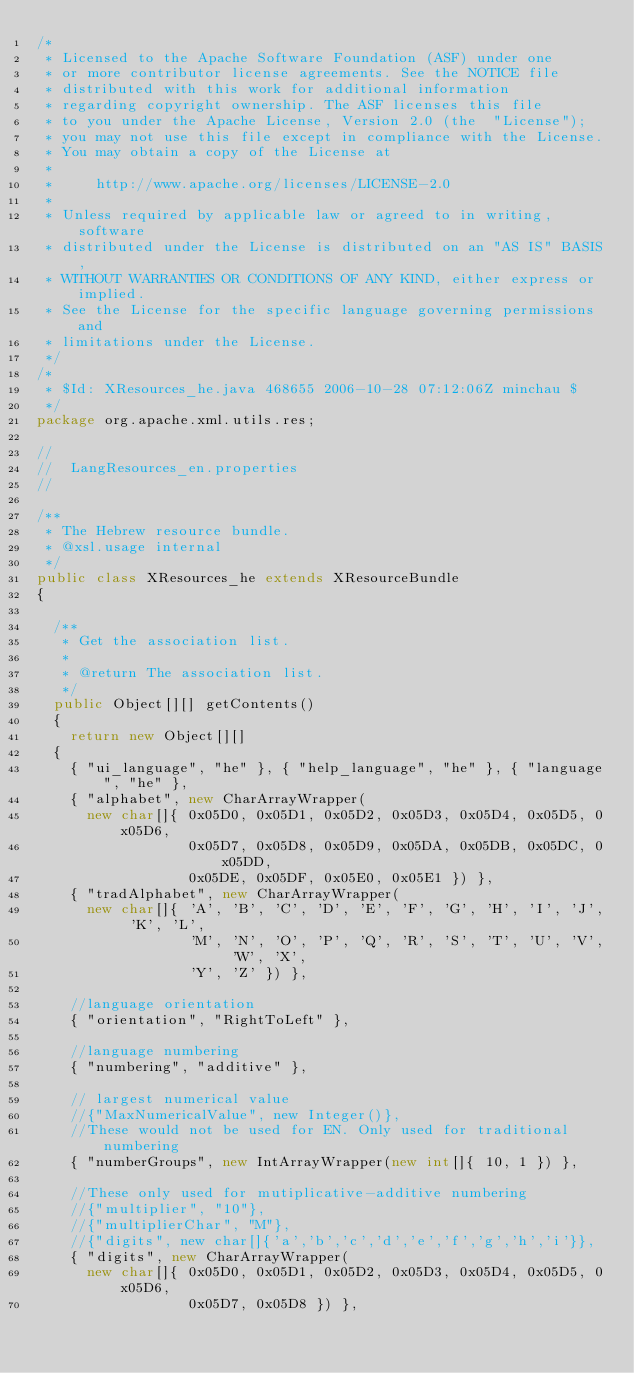Convert code to text. <code><loc_0><loc_0><loc_500><loc_500><_Java_>/*
 * Licensed to the Apache Software Foundation (ASF) under one
 * or more contributor license agreements. See the NOTICE file
 * distributed with this work for additional information
 * regarding copyright ownership. The ASF licenses this file
 * to you under the Apache License, Version 2.0 (the  "License");
 * you may not use this file except in compliance with the License.
 * You may obtain a copy of the License at
 *
 *     http://www.apache.org/licenses/LICENSE-2.0
 *
 * Unless required by applicable law or agreed to in writing, software
 * distributed under the License is distributed on an "AS IS" BASIS,
 * WITHOUT WARRANTIES OR CONDITIONS OF ANY KIND, either express or implied.
 * See the License for the specific language governing permissions and
 * limitations under the License.
 */
/*
 * $Id: XResources_he.java 468655 2006-10-28 07:12:06Z minchau $
 */
package org.apache.xml.utils.res;

//
//  LangResources_en.properties
//

/**
 * The Hebrew resource bundle.
 * @xsl.usage internal
 */
public class XResources_he extends XResourceBundle
{

  /**
   * Get the association list.
   *
   * @return The association list.
   */
  public Object[][] getContents()
  {
    return new Object[][]
  {
    { "ui_language", "he" }, { "help_language", "he" }, { "language", "he" },
    { "alphabet", new CharArrayWrapper(
      new char[]{ 0x05D0, 0x05D1, 0x05D2, 0x05D3, 0x05D4, 0x05D5, 0x05D6,
                  0x05D7, 0x05D8, 0x05D9, 0x05DA, 0x05DB, 0x05DC, 0x05DD,
                  0x05DE, 0x05DF, 0x05E0, 0x05E1 }) },
    { "tradAlphabet", new CharArrayWrapper(
      new char[]{ 'A', 'B', 'C', 'D', 'E', 'F', 'G', 'H', 'I', 'J', 'K', 'L',
                  'M', 'N', 'O', 'P', 'Q', 'R', 'S', 'T', 'U', 'V', 'W', 'X',
                  'Y', 'Z' }) },

    //language orientation
    { "orientation", "RightToLeft" },

    //language numbering   
    { "numbering", "additive" },

    // largest numerical value
    //{"MaxNumericalValue", new Integer()},
    //These would not be used for EN. Only used for traditional numbering   
    { "numberGroups", new IntArrayWrapper(new int[]{ 10, 1 }) },

    //These only used for mutiplicative-additive numbering
    //{"multiplier", "10"},
    //{"multiplierChar", "M"}, 
    //{"digits", new char[]{'a','b','c','d','e','f','g','h','i'}},
    { "digits", new CharArrayWrapper(
      new char[]{ 0x05D0, 0x05D1, 0x05D2, 0x05D3, 0x05D4, 0x05D5, 0x05D6,
                  0x05D7, 0x05D8 }) },</code> 